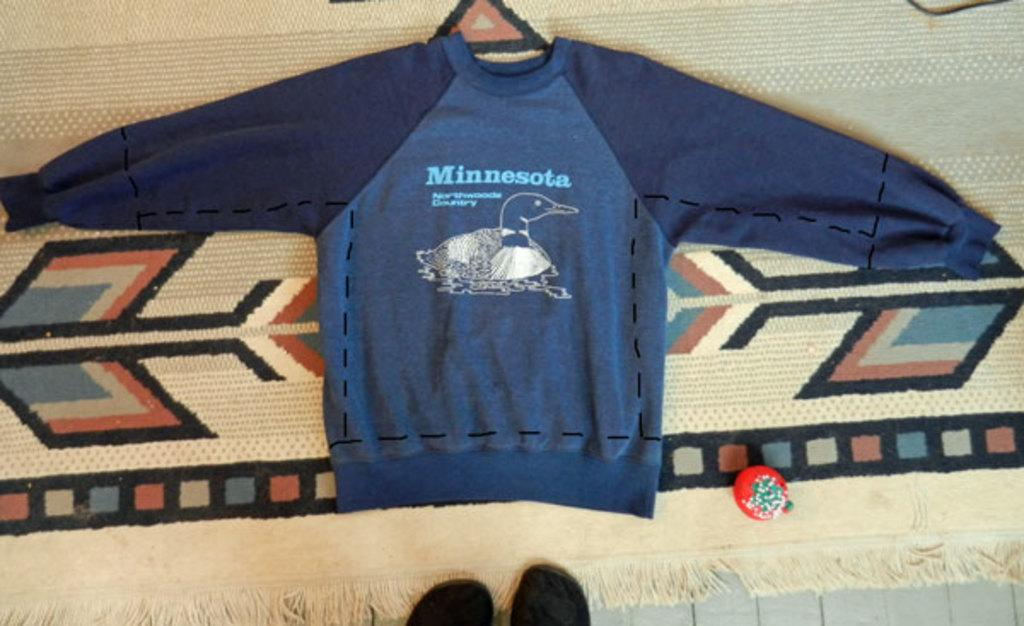What color is the t-shirt in the image? The t-shirt in the image is blue. What part of a person can be seen in the image? The legs of a person are visible in the image. What type of thought is the person having while wearing the blue t-shirt in the image? There is no information about the person's thoughts in the image, so we cannot determine what they might be thinking. 